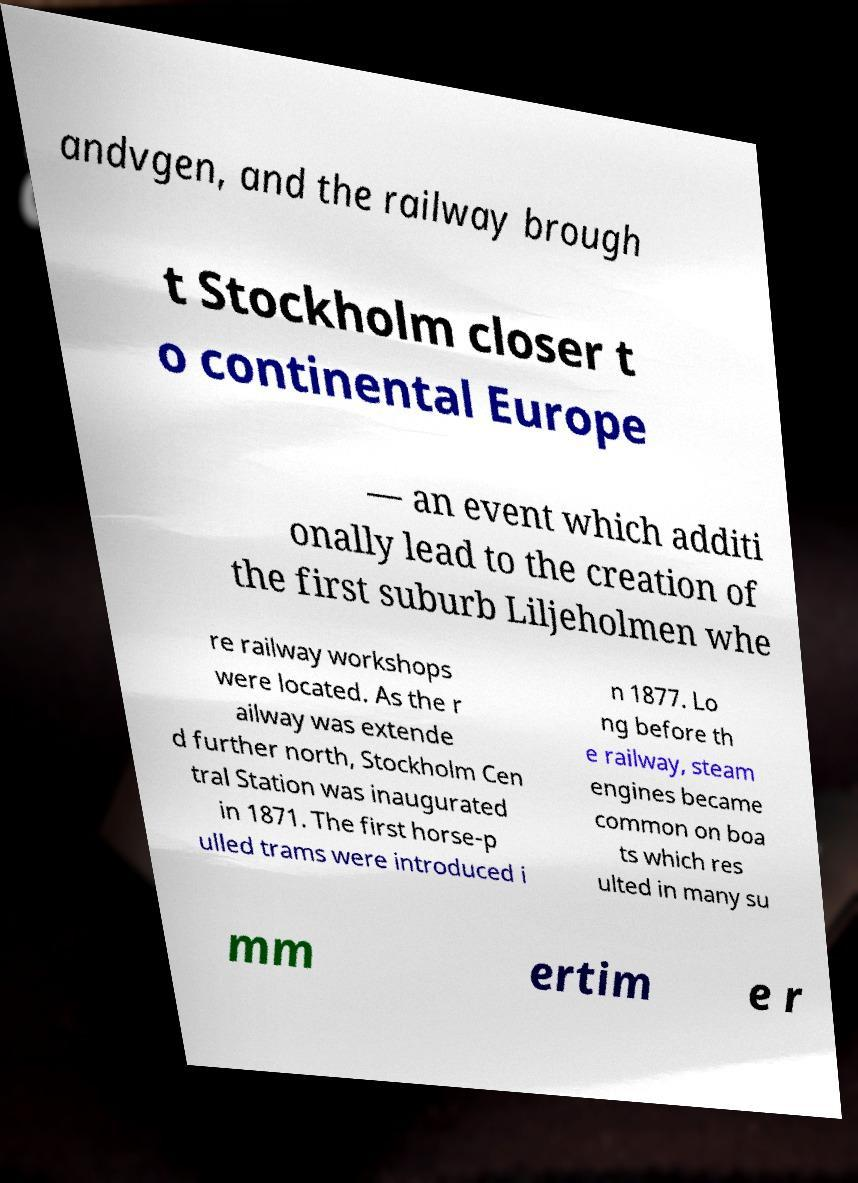For documentation purposes, I need the text within this image transcribed. Could you provide that? andvgen, and the railway brough t Stockholm closer t o continental Europe — an event which additi onally lead to the creation of the first suburb Liljeholmen whe re railway workshops were located. As the r ailway was extende d further north, Stockholm Cen tral Station was inaugurated in 1871. The first horse-p ulled trams were introduced i n 1877. Lo ng before th e railway, steam engines became common on boa ts which res ulted in many su mm ertim e r 